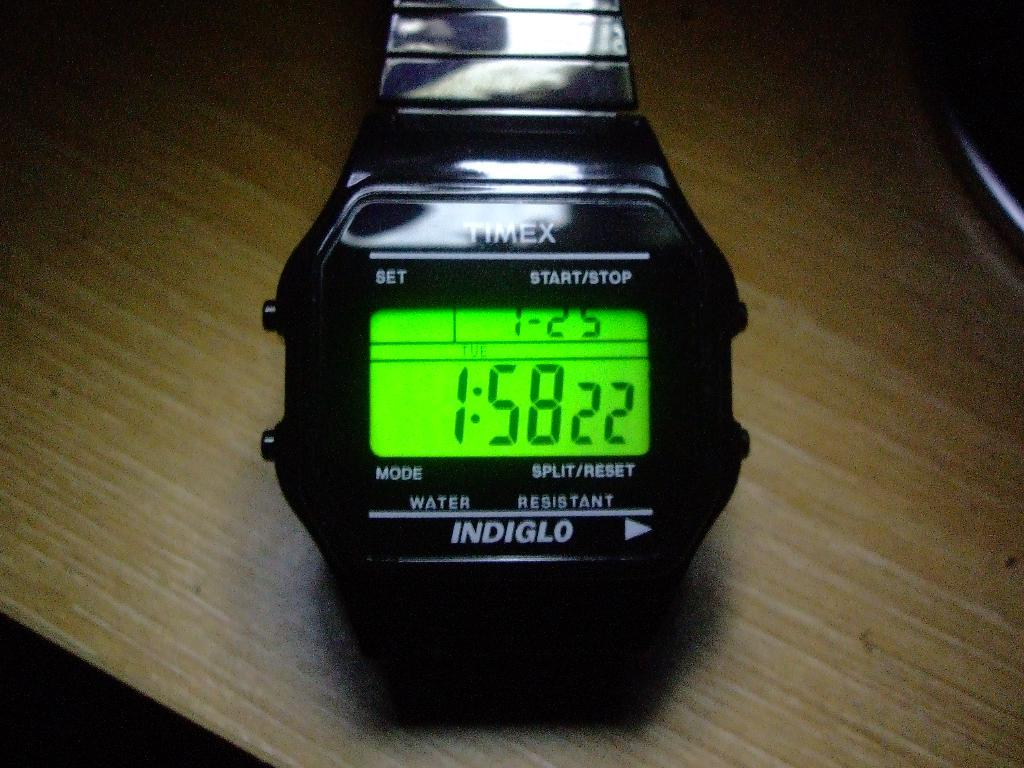<image>
Give a short and clear explanation of the subsequent image. A timex Indiglo digital watch with the time showing 1:58. 